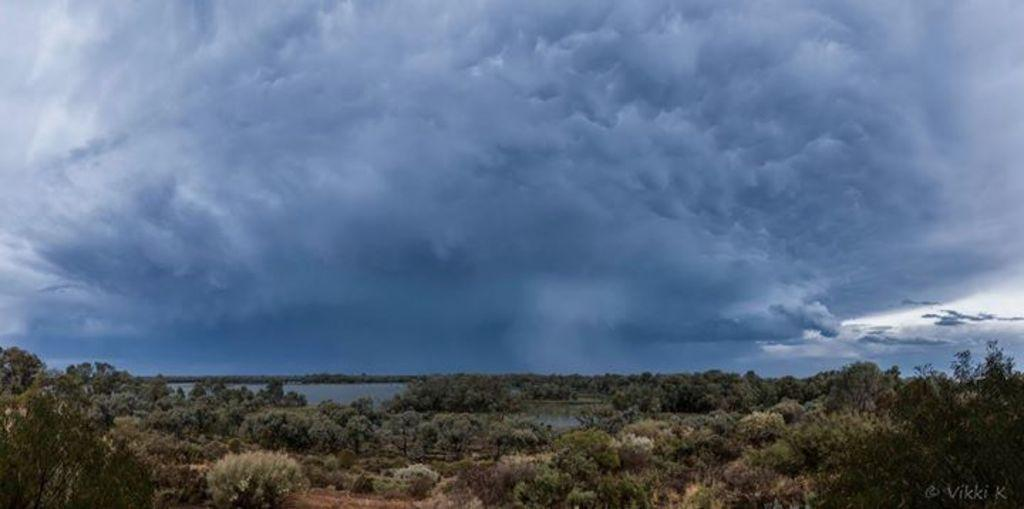What is visible in the sky in the image? The sky is visible in the image, and clouds are present. What else can be seen in the image besides the sky? There is water, trees, and the ground visible in the image. Can you describe the ground in the image? The ground is visible in the image, but no specific details about its texture or composition are provided. Where is the creator of the image located? The creator of the image is not present in the image, so their location cannot be determined. What type of force is being exerted on the water in the image? There is no indication of any force being exerted on the water in the image. 